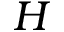Convert formula to latex. <formula><loc_0><loc_0><loc_500><loc_500>H</formula> 